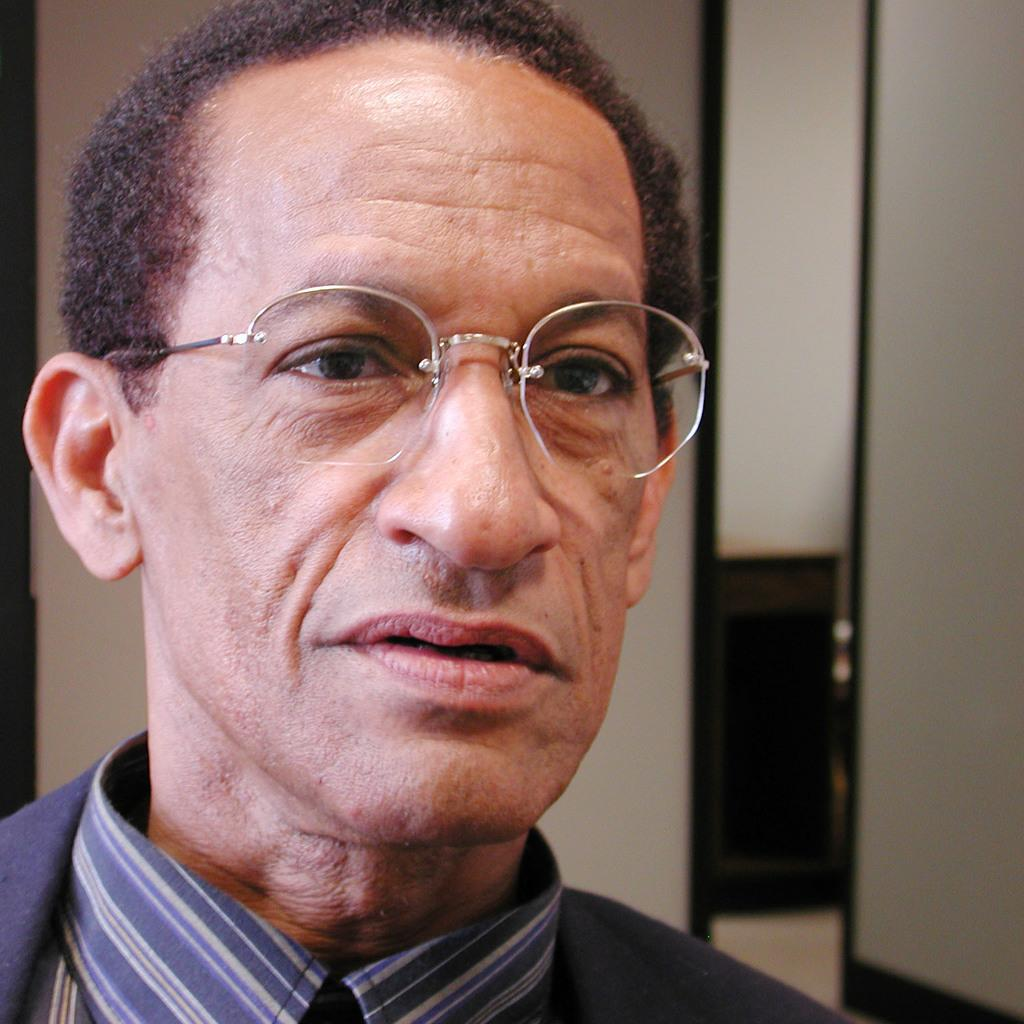What is present in the picture? There is a man in the picture. What is the man wearing on his upper body? The man is wearing a shirt. What accessory is the man wearing on his face? The man is wearing spectacles. What type of hair is visible on the man's head in the image? There is no information about the man's hair in the provided facts, so we cannot determine the type of hair visible on his head. 